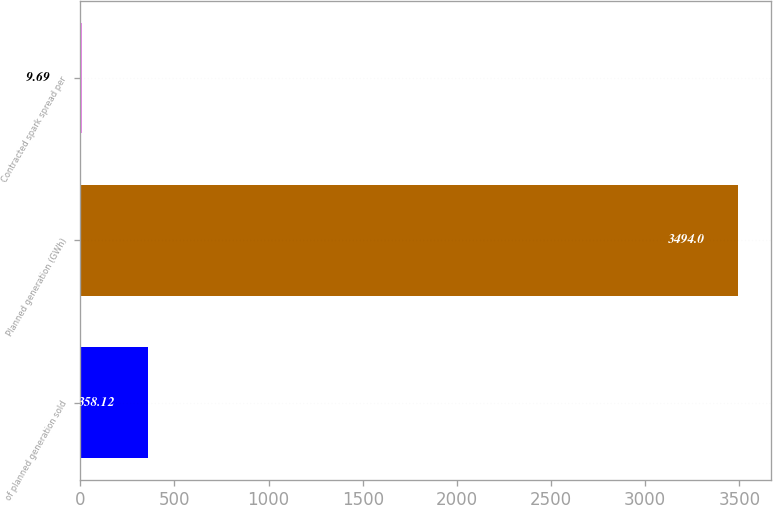Convert chart. <chart><loc_0><loc_0><loc_500><loc_500><bar_chart><fcel>of planned generation sold<fcel>Planned generation (GWh)<fcel>Contracted spark spread per<nl><fcel>358.12<fcel>3494<fcel>9.69<nl></chart> 